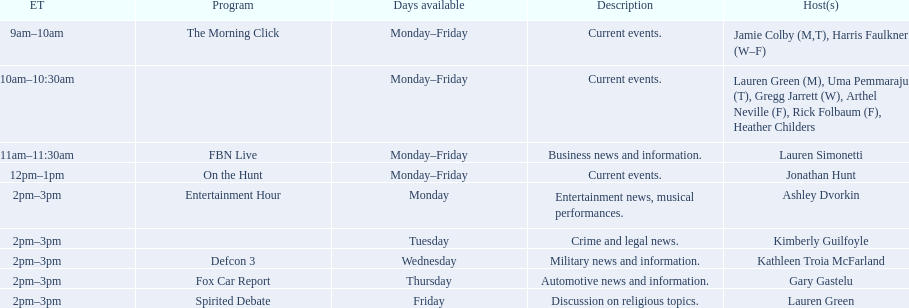Which program is only available on thursdays? Fox Car Report. 